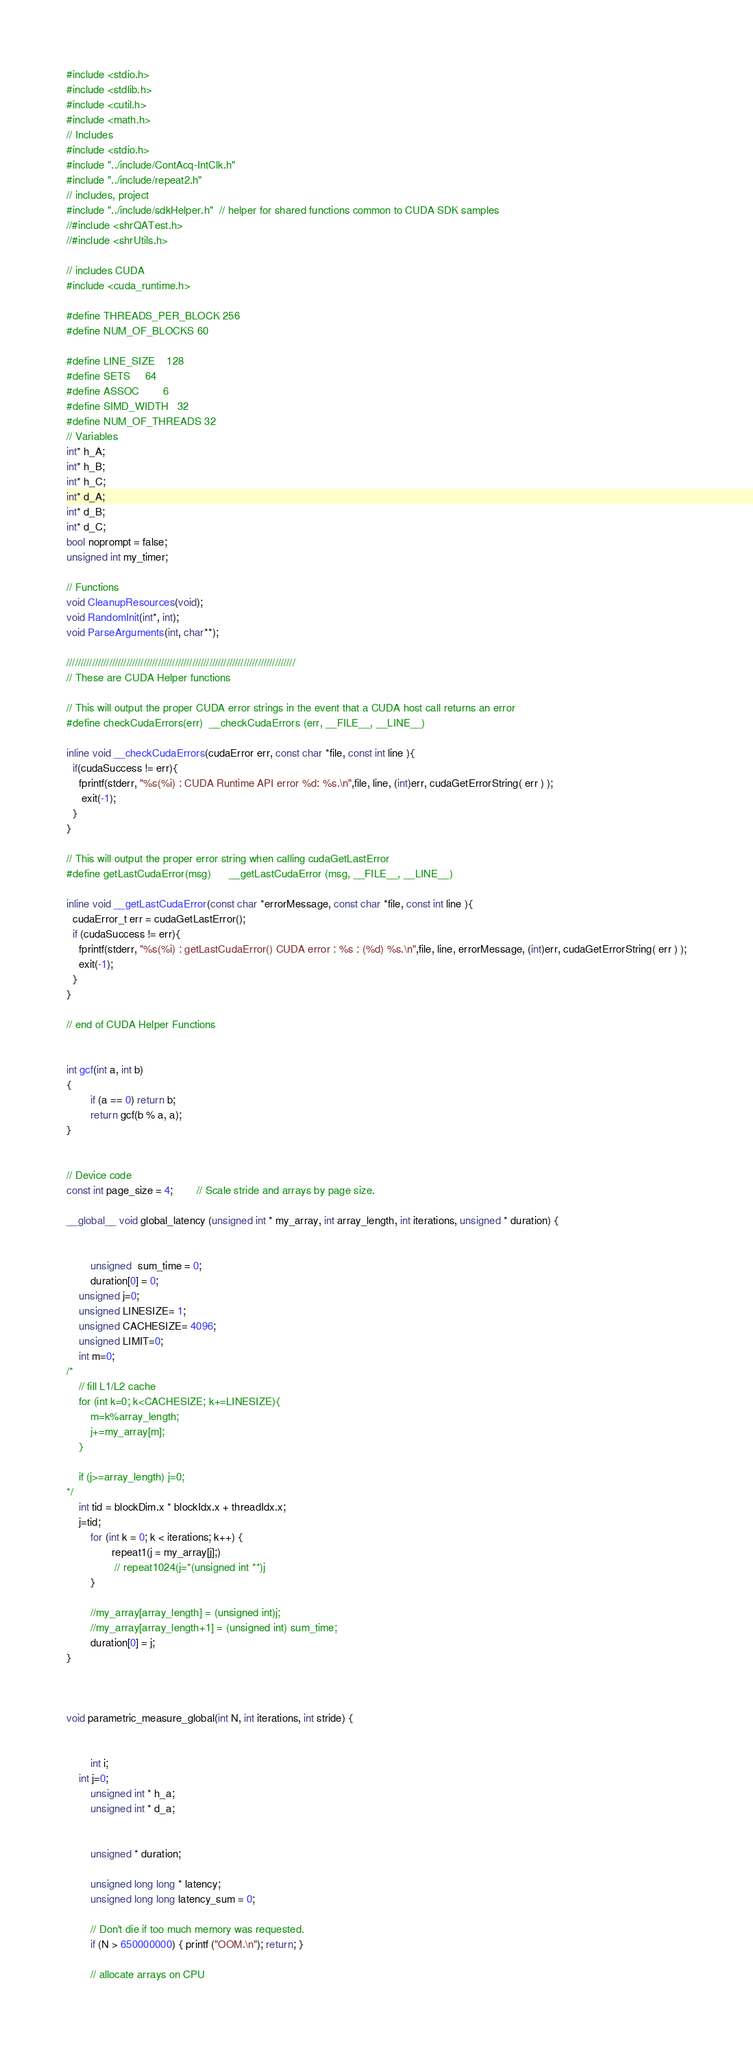<code> <loc_0><loc_0><loc_500><loc_500><_Cuda_>#include <stdio.h>
#include <stdlib.h>
#include <cutil.h>
#include <math.h>
// Includes
#include <stdio.h>
#include "../include/ContAcq-IntClk.h"
#include "../include/repeat2.h"
// includes, project
#include "../include/sdkHelper.h"  // helper for shared functions common to CUDA SDK samples
//#include <shrQATest.h>
//#include <shrUtils.h>

// includes CUDA
#include <cuda_runtime.h>

#define THREADS_PER_BLOCK 256
#define NUM_OF_BLOCKS 60

#define LINE_SIZE 	128
#define SETS		64
#define ASSOC		6
#define SIMD_WIDTH	32
#define NUM_OF_THREADS 32
// Variables
int* h_A;
int* h_B;
int* h_C;
int* d_A;
int* d_B;
int* d_C;
bool noprompt = false;
unsigned int my_timer;

// Functions
void CleanupResources(void);
void RandomInit(int*, int);
void ParseArguments(int, char**);

////////////////////////////////////////////////////////////////////////////////
// These are CUDA Helper functions

// This will output the proper CUDA error strings in the event that a CUDA host call returns an error
#define checkCudaErrors(err)  __checkCudaErrors (err, __FILE__, __LINE__)

inline void __checkCudaErrors(cudaError err, const char *file, const int line ){
  if(cudaSuccess != err){
	fprintf(stderr, "%s(%i) : CUDA Runtime API error %d: %s.\n",file, line, (int)err, cudaGetErrorString( err ) );
	 exit(-1);
  }
}

// This will output the proper error string when calling cudaGetLastError
#define getLastCudaError(msg)      __getLastCudaError (msg, __FILE__, __LINE__)

inline void __getLastCudaError(const char *errorMessage, const char *file, const int line ){
  cudaError_t err = cudaGetLastError();
  if (cudaSuccess != err){
	fprintf(stderr, "%s(%i) : getLastCudaError() CUDA error : %s : (%d) %s.\n",file, line, errorMessage, (int)err, cudaGetErrorString( err ) );
	exit(-1);
  }
}

// end of CUDA Helper Functions


int gcf(int a, int b)
{
        if (a == 0) return b;
        return gcf(b % a, a);
}


// Device code
const int page_size = 4;        // Scale stride and arrays by page size.

__global__ void global_latency (unsigned int * my_array, int array_length, int iterations, unsigned * duration) {

    
        unsigned  sum_time = 0;
        duration[0] = 0;
	unsigned j=0;
	unsigned LINESIZE= 1;
	unsigned CACHESIZE= 4096;
	unsigned LIMIT=0;
	int m=0;
/*
	// fill L1/L2 cache
	for (int k=0; k<CACHESIZE; k+=LINESIZE){
		m=k%array_length;
		j+=my_array[m];
	} 
	       
	if (j>=array_length) j=0;
*/
	int tid = blockDim.x * blockIdx.x + threadIdx.x;
	j=tid;
        for (int k = 0; k < iterations; k++) {
               repeat1(j = my_array[j];)
                // repeat1024(j=*(unsigned int **)j
        }

        //my_array[array_length] = (unsigned int)j;
        //my_array[array_length+1] = (unsigned int) sum_time;
        duration[0] = j;
}



void parametric_measure_global(int N, int iterations, int stride) {


        int i;
	int j=0;
        unsigned int * h_a;
        unsigned int * d_a;


        unsigned * duration;

        unsigned long long * latency;
        unsigned long long latency_sum = 0;

        // Don't die if too much memory was requested.
        if (N > 650000000) { printf ("OOM.\n"); return; }

        // allocate arrays on CPU </code> 